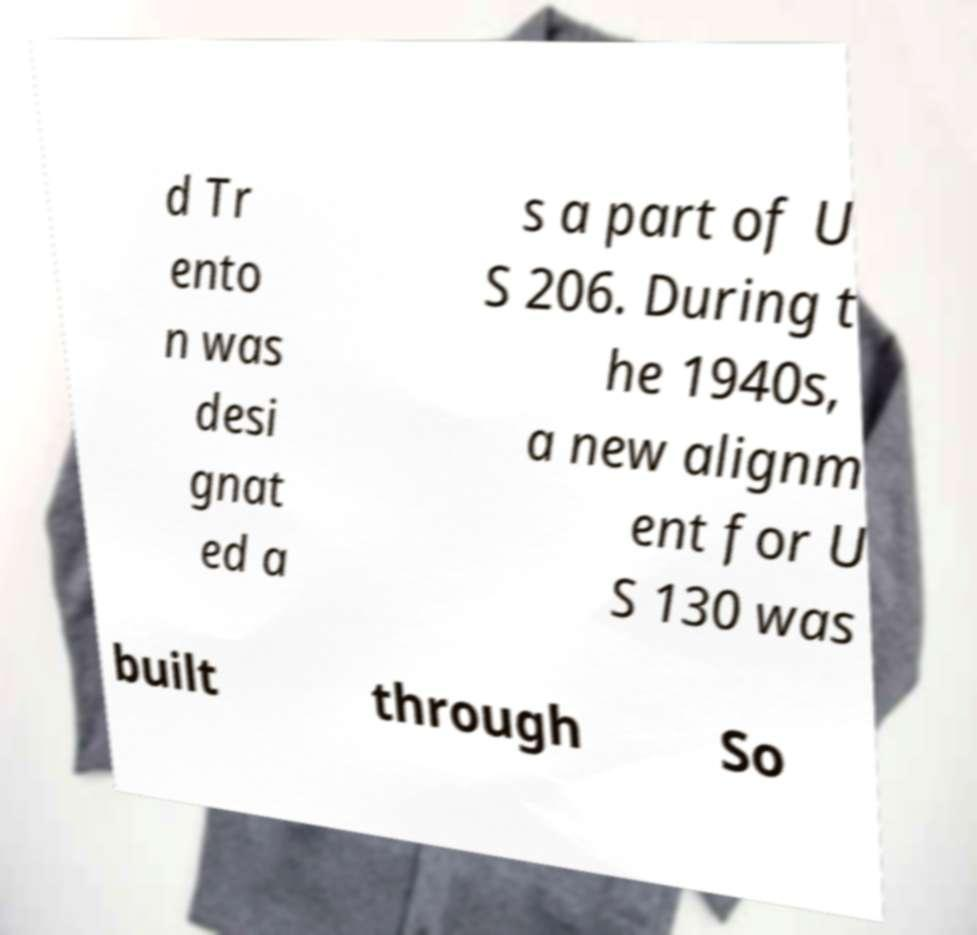For documentation purposes, I need the text within this image transcribed. Could you provide that? d Tr ento n was desi gnat ed a s a part of U S 206. During t he 1940s, a new alignm ent for U S 130 was built through So 